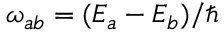<formula> <loc_0><loc_0><loc_500><loc_500>\omega _ { a b } = ( E _ { a } - E _ { b } ) / \hbar</formula> 